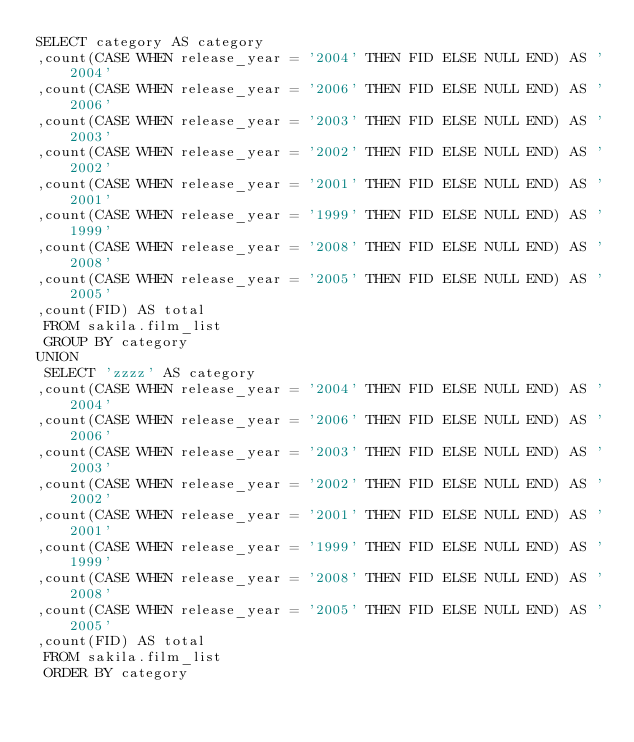<code> <loc_0><loc_0><loc_500><loc_500><_SQL_>SELECT category AS category 
,count(CASE WHEN release_year = '2004' THEN FID ELSE NULL END) AS '2004' 
,count(CASE WHEN release_year = '2006' THEN FID ELSE NULL END) AS '2006' 
,count(CASE WHEN release_year = '2003' THEN FID ELSE NULL END) AS '2003' 
,count(CASE WHEN release_year = '2002' THEN FID ELSE NULL END) AS '2002' 
,count(CASE WHEN release_year = '2001' THEN FID ELSE NULL END) AS '2001' 
,count(CASE WHEN release_year = '1999' THEN FID ELSE NULL END) AS '1999' 
,count(CASE WHEN release_year = '2008' THEN FID ELSE NULL END) AS '2008' 
,count(CASE WHEN release_year = '2005' THEN FID ELSE NULL END) AS '2005' 
,count(FID) AS total
 FROM sakila.film_list 
 GROUP BY category
UNION
 SELECT 'zzzz' AS category
,count(CASE WHEN release_year = '2004' THEN FID ELSE NULL END) AS '2004' 
,count(CASE WHEN release_year = '2006' THEN FID ELSE NULL END) AS '2006' 
,count(CASE WHEN release_year = '2003' THEN FID ELSE NULL END) AS '2003' 
,count(CASE WHEN release_year = '2002' THEN FID ELSE NULL END) AS '2002' 
,count(CASE WHEN release_year = '2001' THEN FID ELSE NULL END) AS '2001' 
,count(CASE WHEN release_year = '1999' THEN FID ELSE NULL END) AS '1999' 
,count(CASE WHEN release_year = '2008' THEN FID ELSE NULL END) AS '2008' 
,count(CASE WHEN release_year = '2005' THEN FID ELSE NULL END) AS '2005' 
,count(FID) AS total
 FROM sakila.film_list 
 ORDER BY category

</code> 